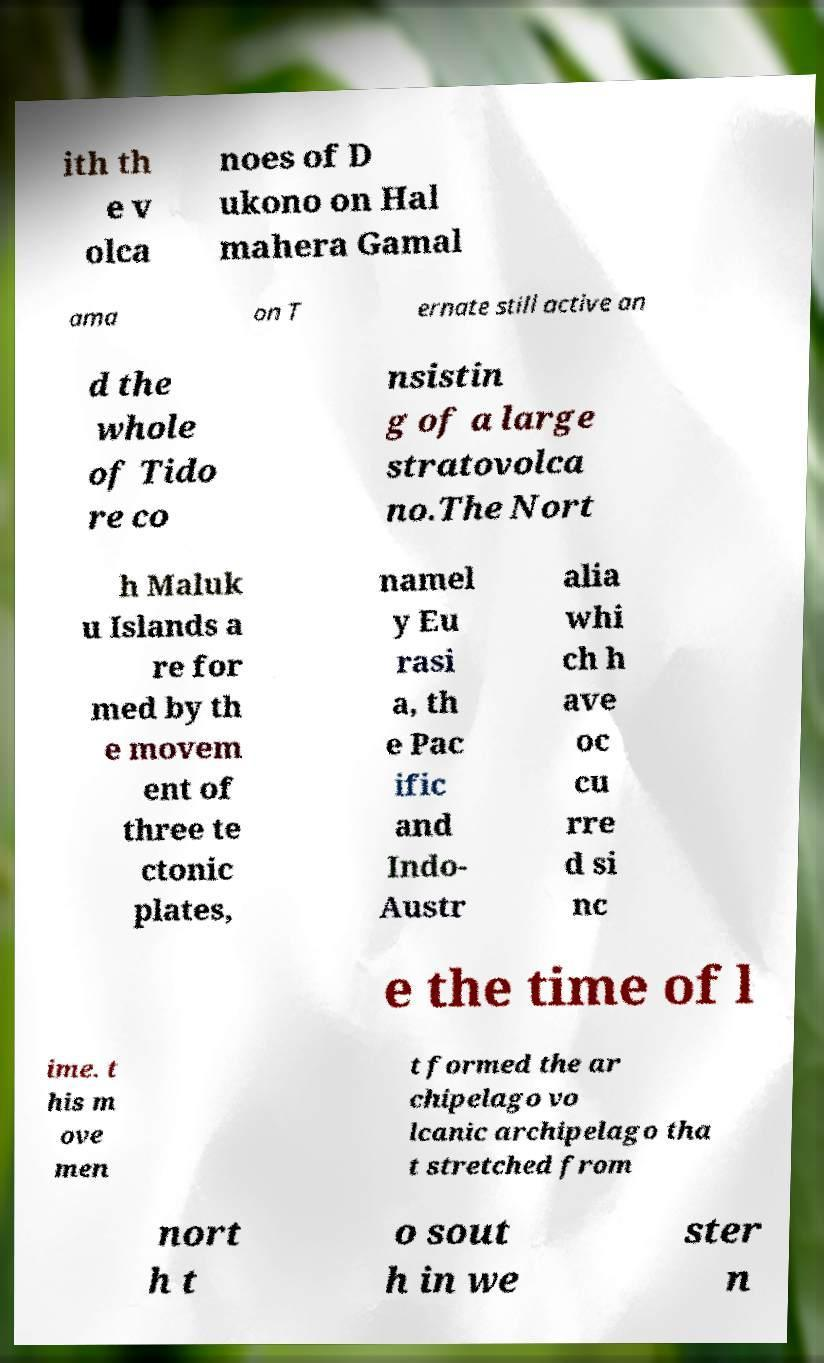Could you extract and type out the text from this image? ith th e v olca noes of D ukono on Hal mahera Gamal ama on T ernate still active an d the whole of Tido re co nsistin g of a large stratovolca no.The Nort h Maluk u Islands a re for med by th e movem ent of three te ctonic plates, namel y Eu rasi a, th e Pac ific and Indo- Austr alia whi ch h ave oc cu rre d si nc e the time of l ime. t his m ove men t formed the ar chipelago vo lcanic archipelago tha t stretched from nort h t o sout h in we ster n 